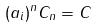<formula> <loc_0><loc_0><loc_500><loc_500>( a _ { i } ) ^ { n } C _ { n } = C</formula> 